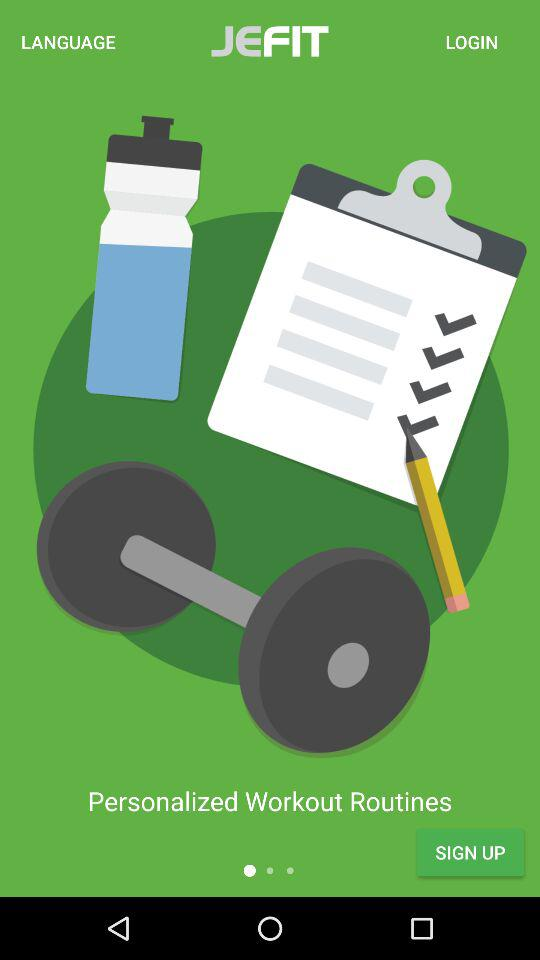What is the name of the application? The name of the application is "JEFIT". 